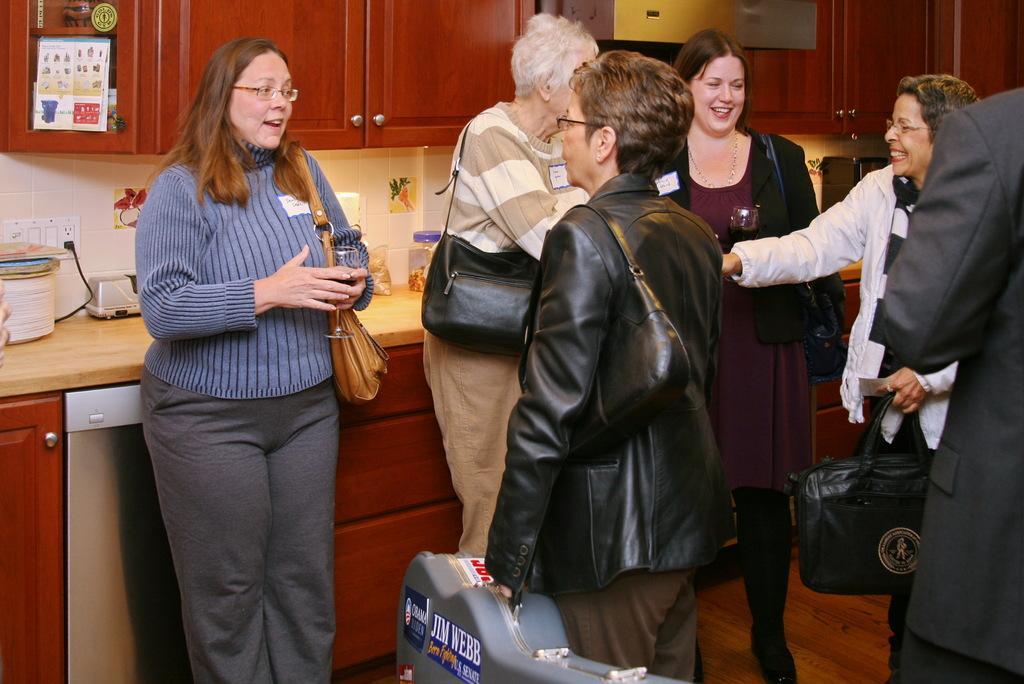Can you describe this image briefly? In this picture, we see five women standing and talking to each other and they are smiling. Woman in black jacket is holding a guitar box in her hand. Behind them, we see a countertop on which plastic box and kettle are placed. At the top of the picture, we see cupboards in brown color and this picture is clicked inside the room. 